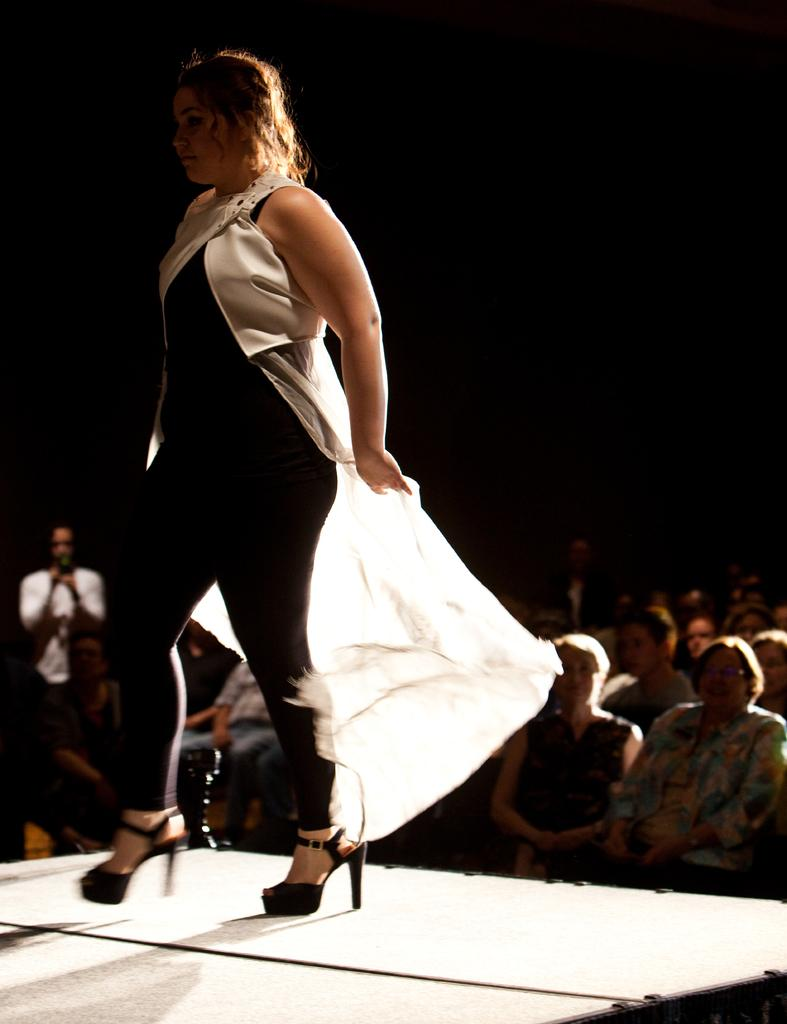Who is the main subject in the image? There is a woman in the image. What is the woman wearing? The woman is wearing a black and white dress. Where is the woman located in the image? The woman is on a platform. What can be seen in the background of the image? There are people in the background of the image, and the background is dark. What type of butter is being used by the woman on the stage? There is no butter present in the image, and the woman is not using any butter. 